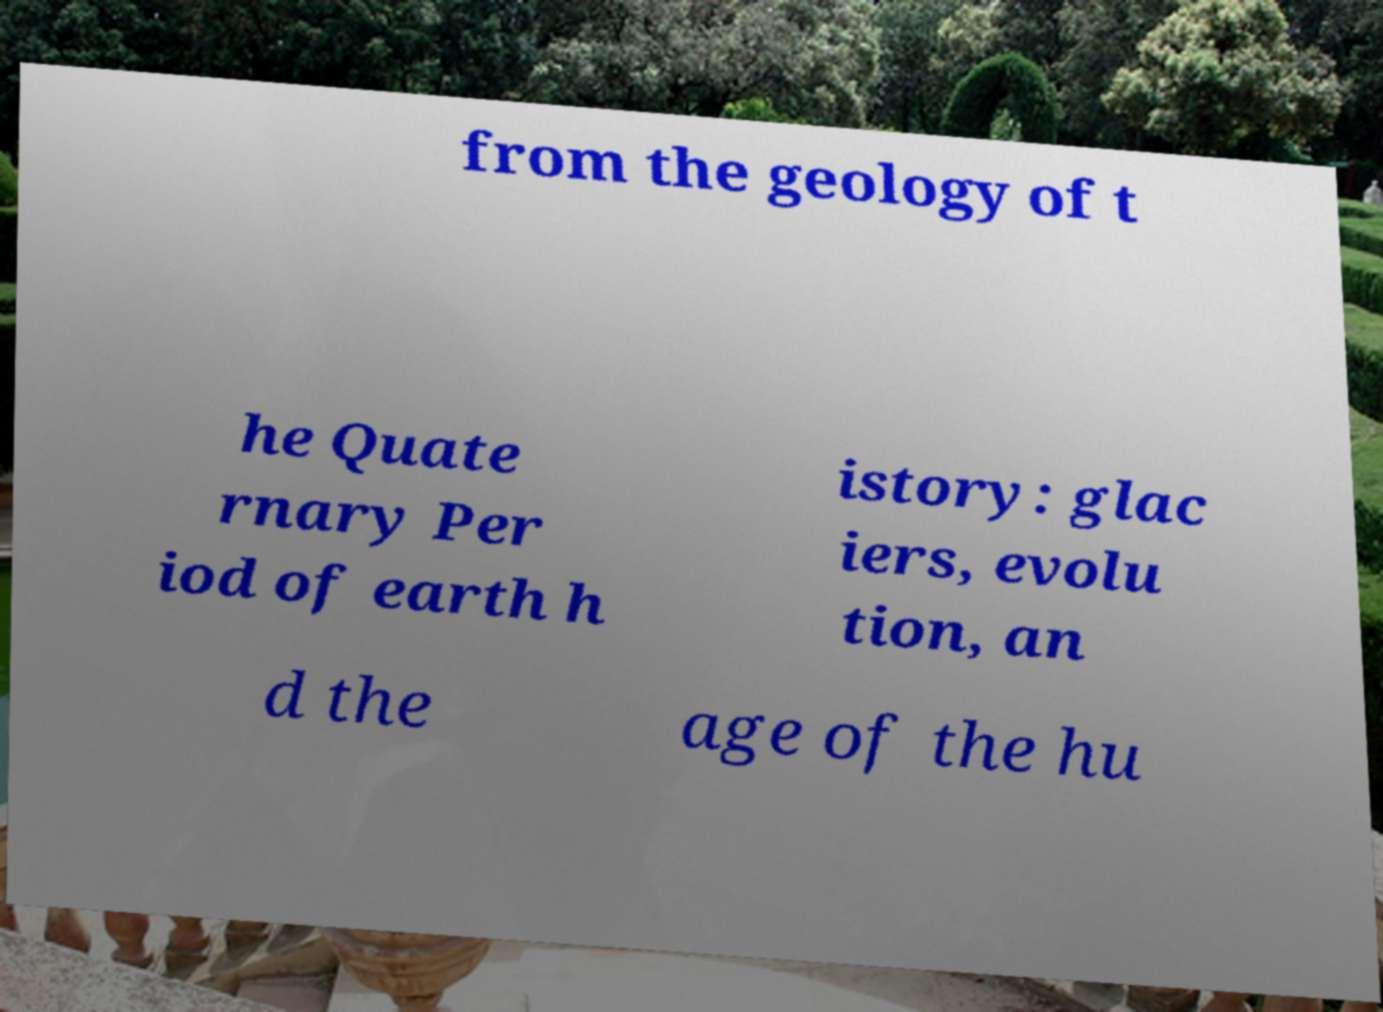There's text embedded in this image that I need extracted. Can you transcribe it verbatim? from the geology of t he Quate rnary Per iod of earth h istory: glac iers, evolu tion, an d the age of the hu 